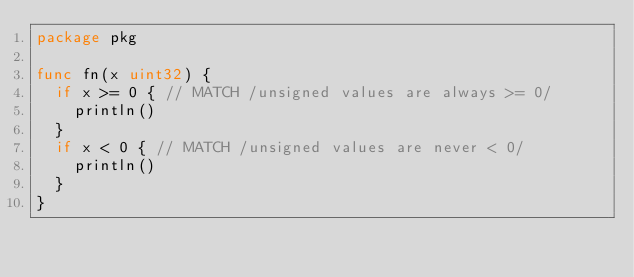<code> <loc_0><loc_0><loc_500><loc_500><_Go_>package pkg

func fn(x uint32) {
	if x >= 0 { // MATCH /unsigned values are always >= 0/
		println()
	}
	if x < 0 { // MATCH /unsigned values are never < 0/
		println()
	}
}
</code> 